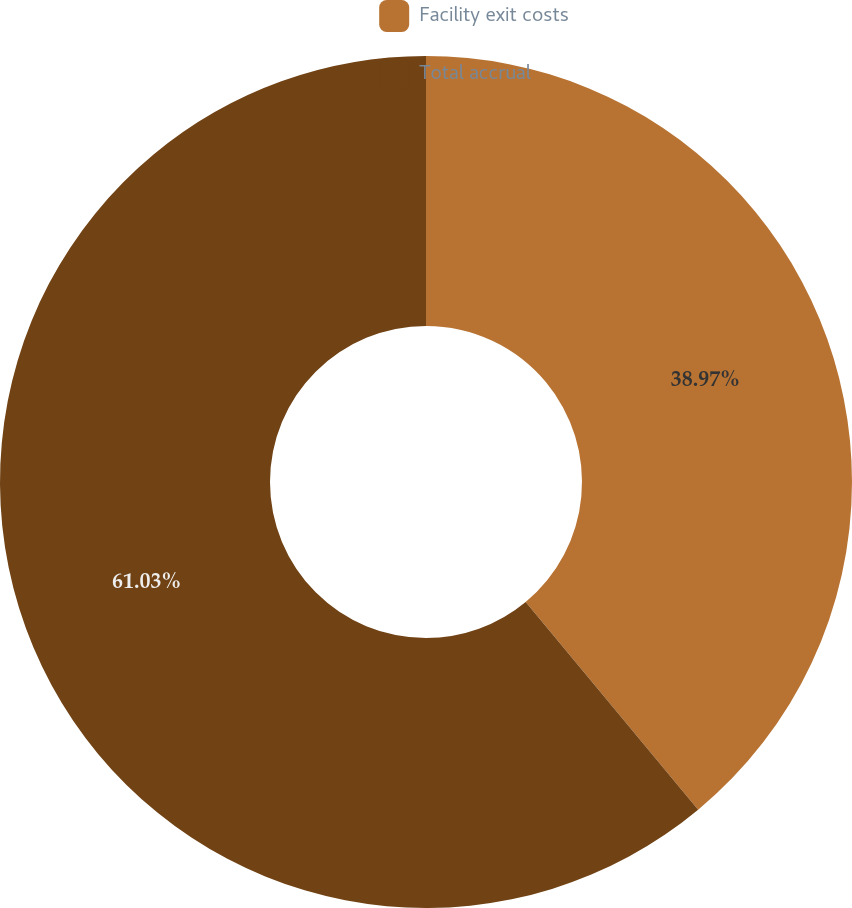<chart> <loc_0><loc_0><loc_500><loc_500><pie_chart><fcel>Facility exit costs<fcel>Total accrual<nl><fcel>38.97%<fcel>61.03%<nl></chart> 